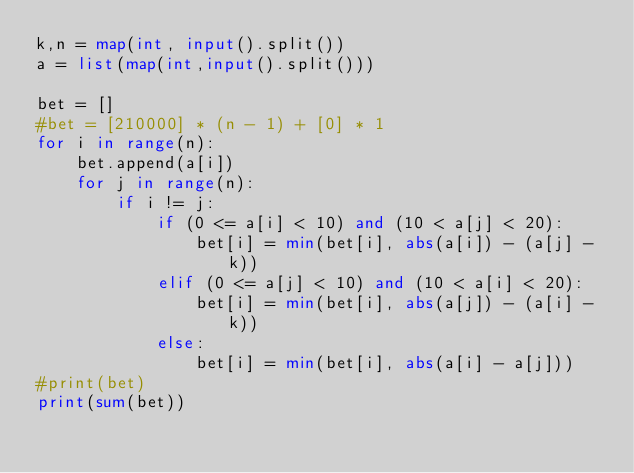<code> <loc_0><loc_0><loc_500><loc_500><_Python_>k,n = map(int, input().split())
a = list(map(int,input().split()))

bet = []
#bet = [210000] * (n - 1) + [0] * 1
for i in range(n):
    bet.append(a[i])
    for j in range(n):
        if i != j:
            if (0 <= a[i] < 10) and (10 < a[j] < 20):
                bet[i] = min(bet[i], abs(a[i]) - (a[j] - k))
            elif (0 <= a[j] < 10) and (10 < a[i] < 20):
                bet[i] = min(bet[i], abs(a[j]) - (a[i] - k))
            else:
                bet[i] = min(bet[i], abs(a[i] - a[j]))
#print(bet)
print(sum(bet))</code> 